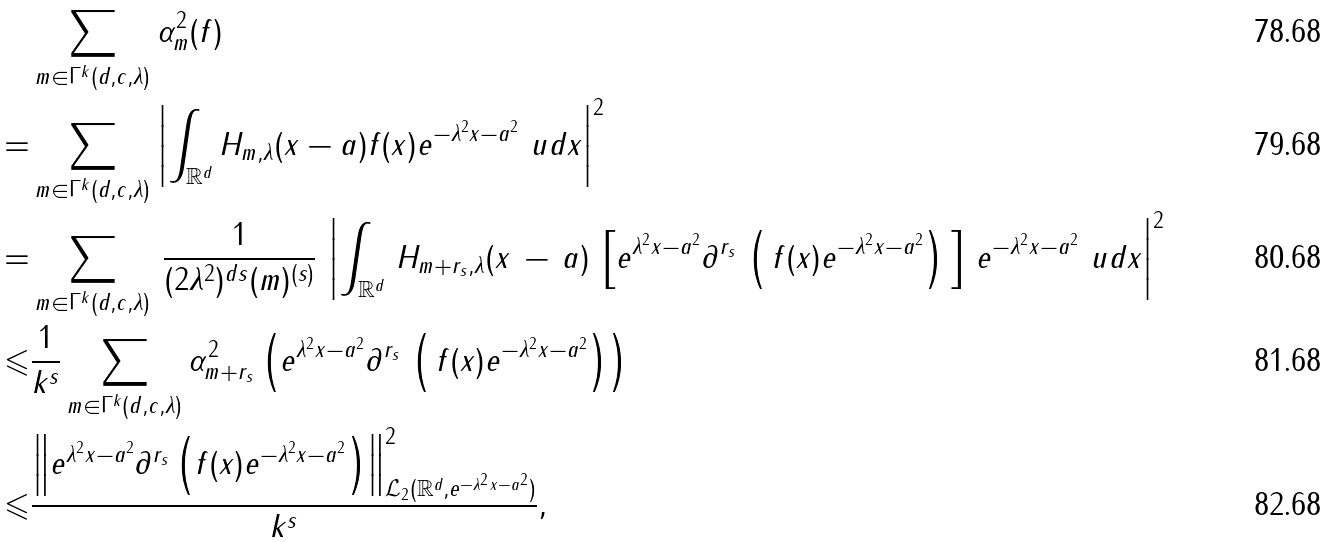<formula> <loc_0><loc_0><loc_500><loc_500>& \sum _ { m \in \Gamma ^ { k } ( d , c , \lambda ) } \alpha _ { m } ^ { 2 } ( f ) \\ = & \sum _ { m \in \Gamma ^ { k } ( d , c , \lambda ) } \left | \int _ { \mathbb { R } ^ { d } } H _ { m , \lambda } ( x - a ) f ( x ) e ^ { - \lambda ^ { 2 } \| x - a \| ^ { 2 } } \ u d x \right | ^ { 2 } \\ = & \sum _ { m \in \Gamma ^ { k } ( d , c , \lambda ) } \, \frac { 1 } { ( 2 \lambda ^ { 2 } ) ^ { d s } ( m ) ^ { ( s ) } } \, \left | \int _ { \mathbb { R } ^ { d } } \, H _ { m + r _ { s } , \lambda } ( x \, - \, a ) \, \left [ e ^ { \lambda ^ { 2 } \| x - a \| ^ { 2 } } \partial ^ { r _ { s } } \, \left ( \, f ( x ) e ^ { - \lambda ^ { 2 } \| x - a \| ^ { 2 } } \right ) \, \right ] \, e ^ { - \lambda ^ { 2 } \| x - a \| ^ { 2 } } \ u d x \right | ^ { 2 } \\ \leqslant & \frac { 1 } { k ^ { s } } \sum _ { m \in \Gamma ^ { k } ( d , c , \lambda ) } \alpha _ { m + r _ { s } } ^ { 2 } \left ( e ^ { \lambda ^ { 2 } \| x - a \| ^ { 2 } } \partial ^ { r _ { s } } \, \left ( \, f ( x ) e ^ { - \lambda ^ { 2 } \| x - a \| ^ { 2 } } \right ) \right ) \\ \leqslant & \frac { \left \| e ^ { \lambda ^ { 2 } \| x - a \| ^ { 2 } } \partial ^ { r _ { s } } \left ( f ( x ) e ^ { - \lambda ^ { 2 } \| x - a \| ^ { 2 } } \right ) \right \| ^ { 2 } _ { \mathcal { L } _ { 2 } ( \mathbb { R } ^ { d } , e ^ { - \lambda ^ { 2 } \| x - a \| ^ { 2 } } ) } } { k ^ { s } } ,</formula> 